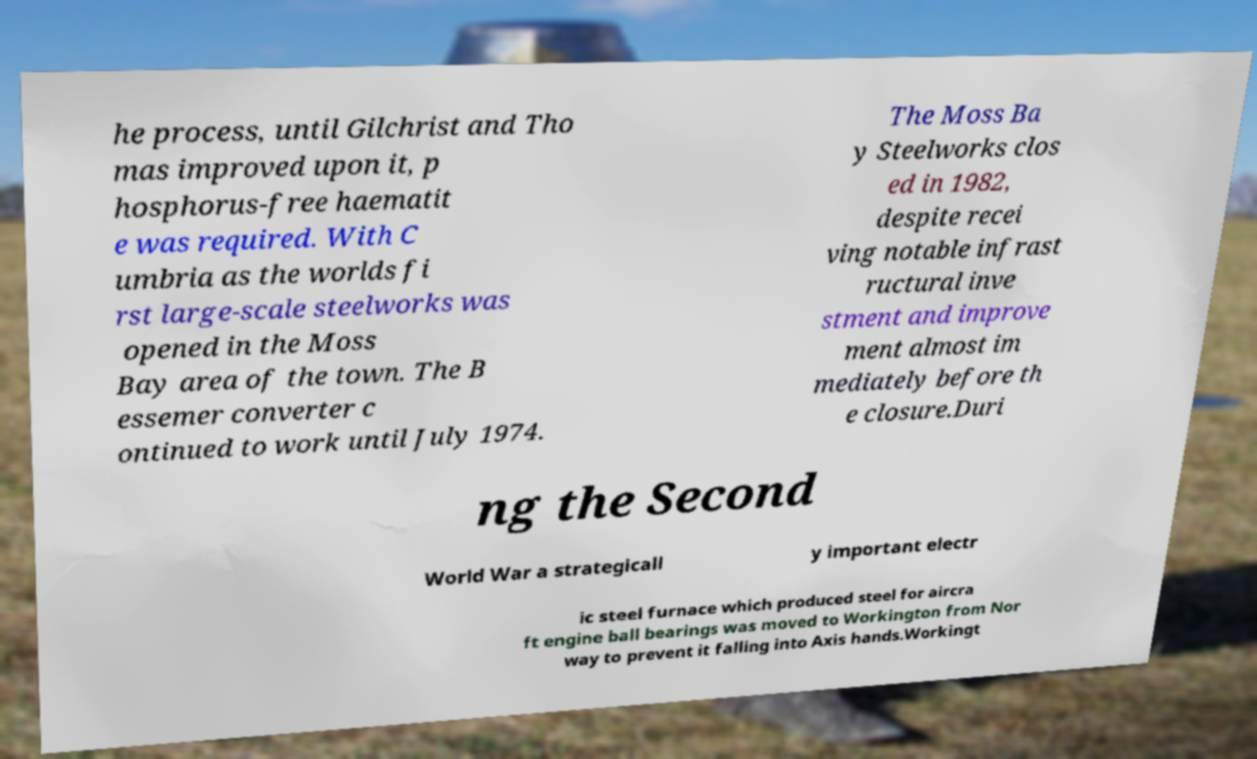There's text embedded in this image that I need extracted. Can you transcribe it verbatim? he process, until Gilchrist and Tho mas improved upon it, p hosphorus-free haematit e was required. With C umbria as the worlds fi rst large-scale steelworks was opened in the Moss Bay area of the town. The B essemer converter c ontinued to work until July 1974. The Moss Ba y Steelworks clos ed in 1982, despite recei ving notable infrast ructural inve stment and improve ment almost im mediately before th e closure.Duri ng the Second World War a strategicall y important electr ic steel furnace which produced steel for aircra ft engine ball bearings was moved to Workington from Nor way to prevent it falling into Axis hands.Workingt 